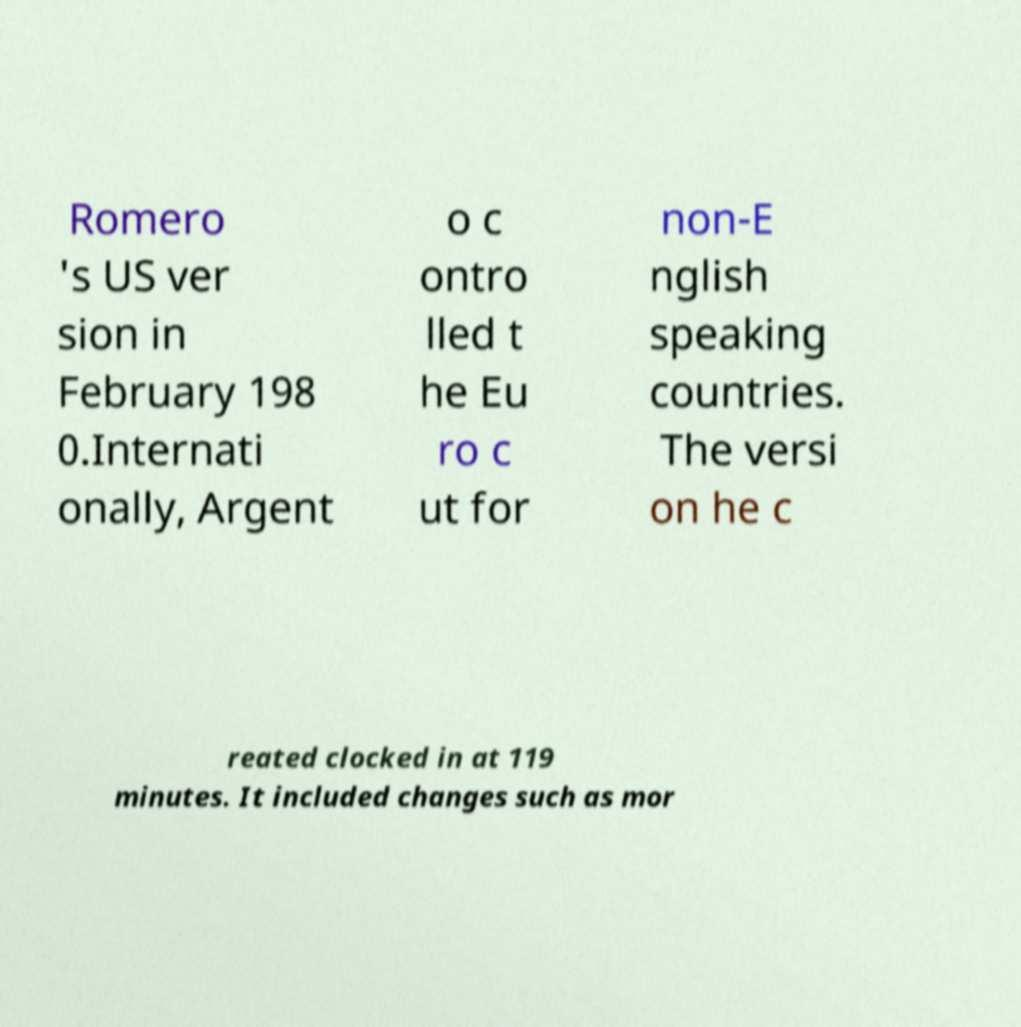I need the written content from this picture converted into text. Can you do that? Romero 's US ver sion in February 198 0.Internati onally, Argent o c ontro lled t he Eu ro c ut for non-E nglish speaking countries. The versi on he c reated clocked in at 119 minutes. It included changes such as mor 